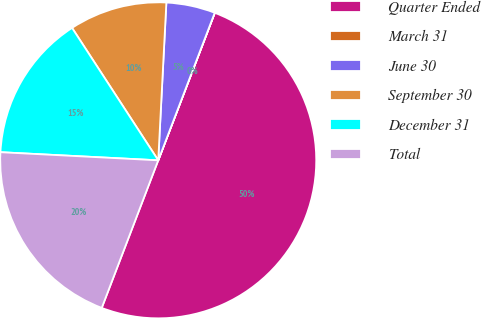Convert chart. <chart><loc_0><loc_0><loc_500><loc_500><pie_chart><fcel>Quarter Ended<fcel>March 31<fcel>June 30<fcel>September 30<fcel>December 31<fcel>Total<nl><fcel>49.99%<fcel>0.01%<fcel>5.0%<fcel>10.0%<fcel>15.0%<fcel>20.0%<nl></chart> 